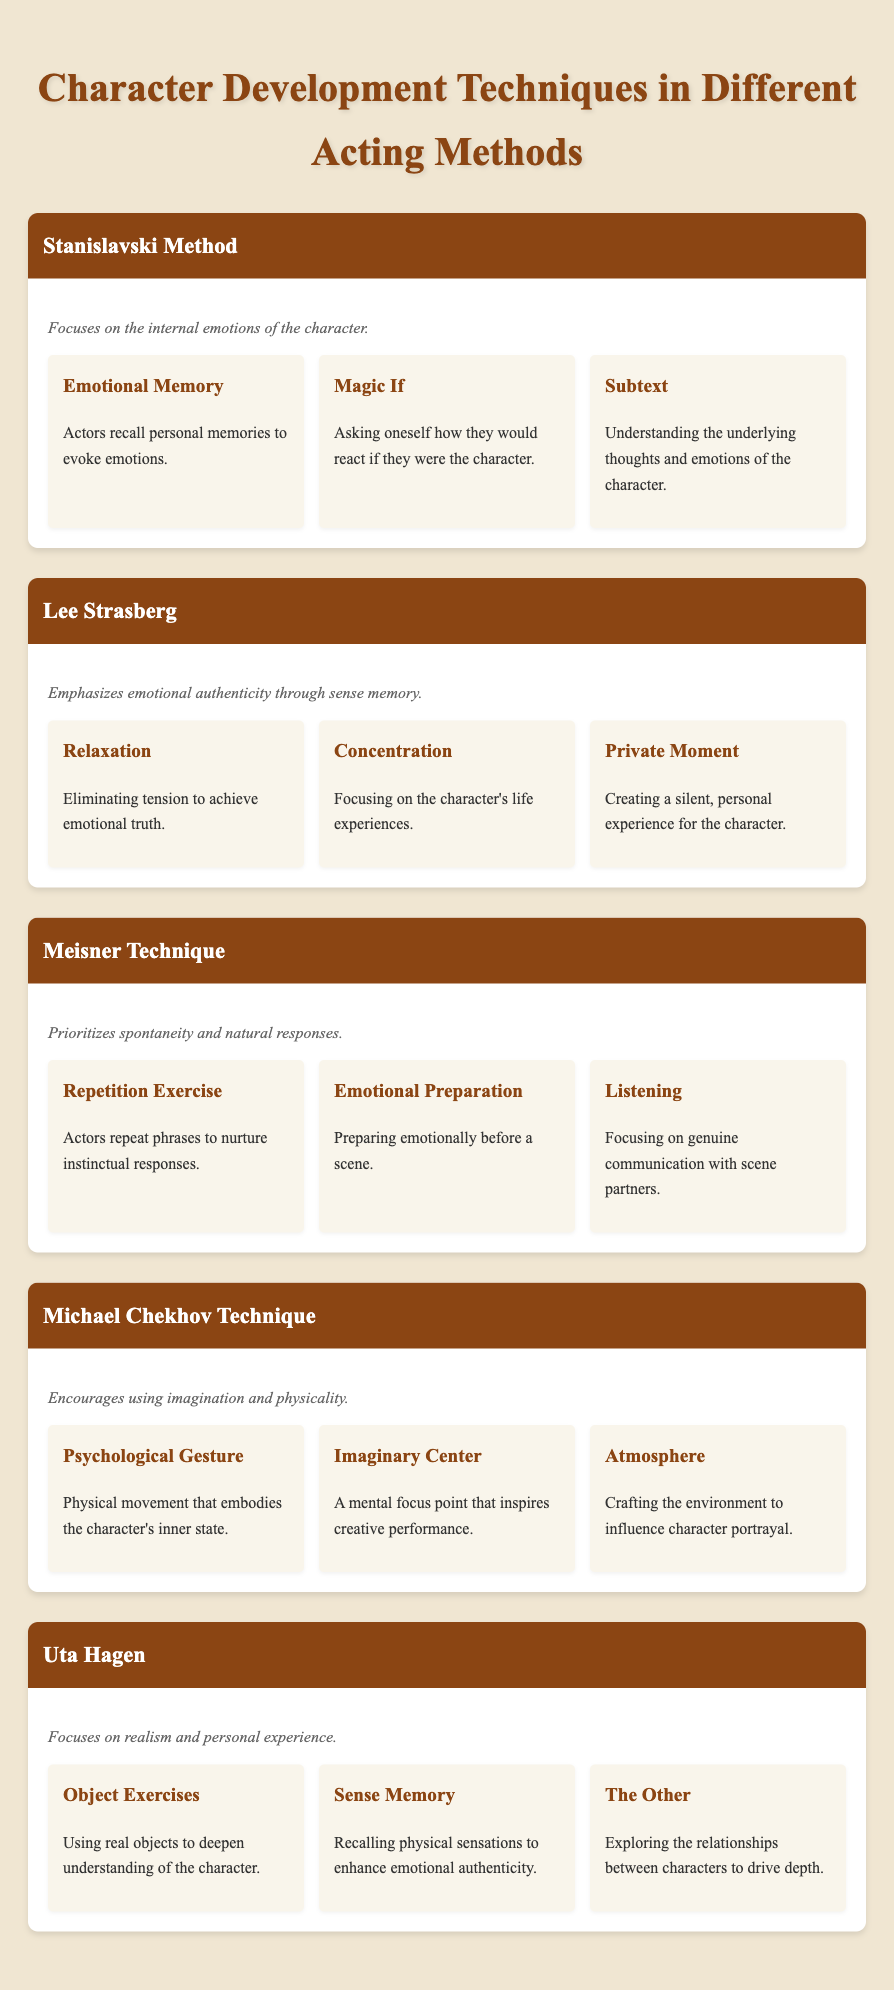What is the primary focus of the Stanislavski Method? The table states that the Stanislavski Method focuses on the internal emotions of the character. This can be found in the Overview section of the Stanislavski Method.
Answer: Internal emotions List one technique used in the Michael Chekhov Technique. The table includes multiple techniques under the Michael Chekhov Technique. One of them mentioned is the Psychological Gesture.
Answer: Psychological Gesture Does the Lee Strasberg method include a technique called 'Relaxation'? In the table, the Lee Strasberg section contains a technique named 'Relaxation', confirming that the statement is true.
Answer: Yes How many techniques does Uta Hagen's method employ? The Uta Hagen section lists three techniques: Object Exercises, Sense Memory, and The Other. This means that the total count of techniques used in Uta Hagen's method is three.
Answer: Three Which acting method emphasizes spontaneity and natural responses? The table indicates that the Meisner Technique prioritizes spontaneity and natural responses, as stated in the Overview section for the Meisner Technique.
Answer: Meisner Technique What is the main idea behind emotional memory in the Stanislavski Method? The technique of emotional memory in the Stanislavski Method involves actors recalling personal memories to evoke emotions, according to the description found in the Techniques section of the method.
Answer: Recall personal memories Are there more techniques in the Uta Hagen method than in the Michael Chekhov Technique? The Uta Hagen method has three techniques listed, while the Michael Chekhov Technique also lists three techniques. Therefore, they have an equal number of techniques, so the answer to the question is no.
Answer: No Identify the technique from the Lee Strasberg method that focuses on the character's life experiences. According to the table, the technique called 'Concentration' focuses on the character's life experiences, which can be found under the Lee Strasberg section.
Answer: Concentration Which method includes the technique 'Listening'? The 'Listening' technique is noted in the Meisner Technique section of the table. Thus, it is identified with the Meisner Technique.
Answer: Meisner Technique What do both the Stanislavski Method and Uta Hagen emphasize in their techniques? Both the Stanislavski Method and Uta Hagen emphasize understanding personal experiences and emotions. The Stanislavski Method focuses on internal emotions, while Uta Hagen focuses on realism and personal experience. This commonality is drawn from the overview descriptions provided in their respective sections.
Answer: Personal experiences and emotions 